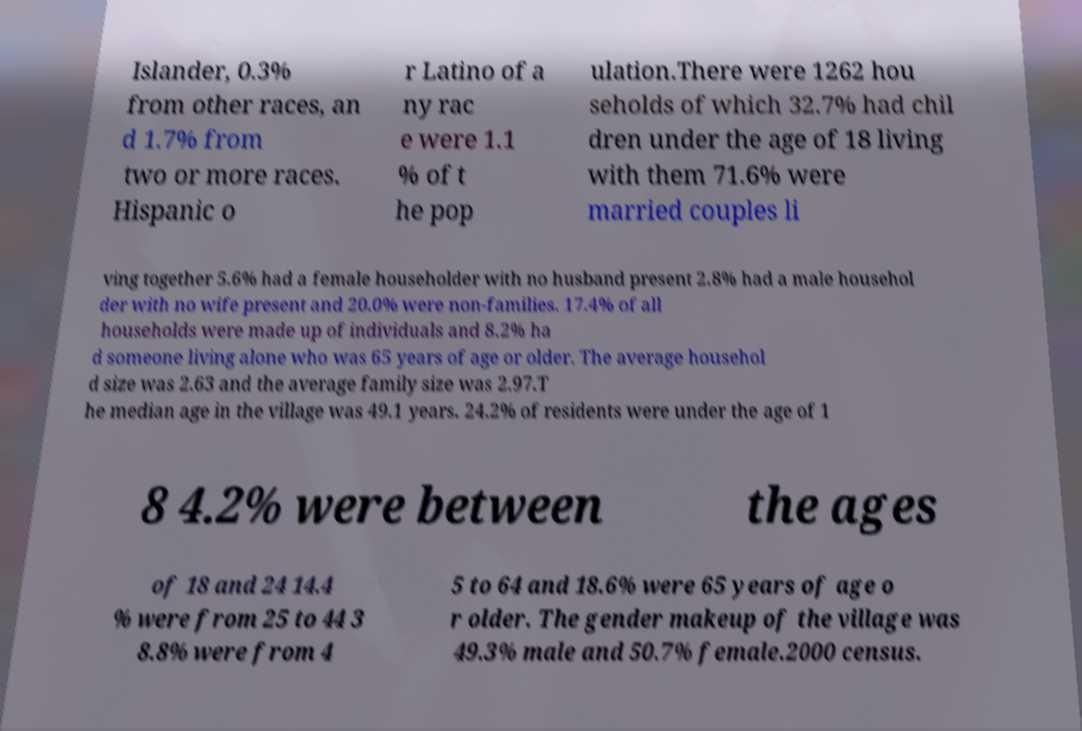Could you assist in decoding the text presented in this image and type it out clearly? Islander, 0.3% from other races, an d 1.7% from two or more races. Hispanic o r Latino of a ny rac e were 1.1 % of t he pop ulation.There were 1262 hou seholds of which 32.7% had chil dren under the age of 18 living with them 71.6% were married couples li ving together 5.6% had a female householder with no husband present 2.8% had a male househol der with no wife present and 20.0% were non-families. 17.4% of all households were made up of individuals and 8.2% ha d someone living alone who was 65 years of age or older. The average househol d size was 2.63 and the average family size was 2.97.T he median age in the village was 49.1 years. 24.2% of residents were under the age of 1 8 4.2% were between the ages of 18 and 24 14.4 % were from 25 to 44 3 8.8% were from 4 5 to 64 and 18.6% were 65 years of age o r older. The gender makeup of the village was 49.3% male and 50.7% female.2000 census. 